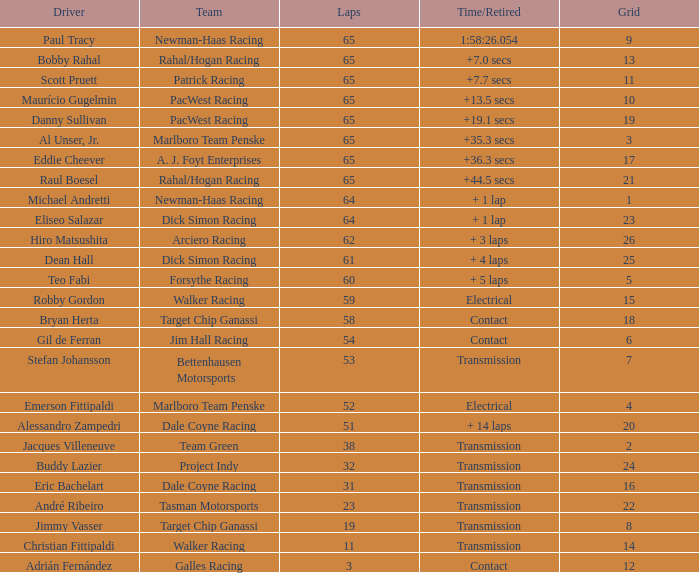What was the peak grid for a time/retired of +1 19.0. 